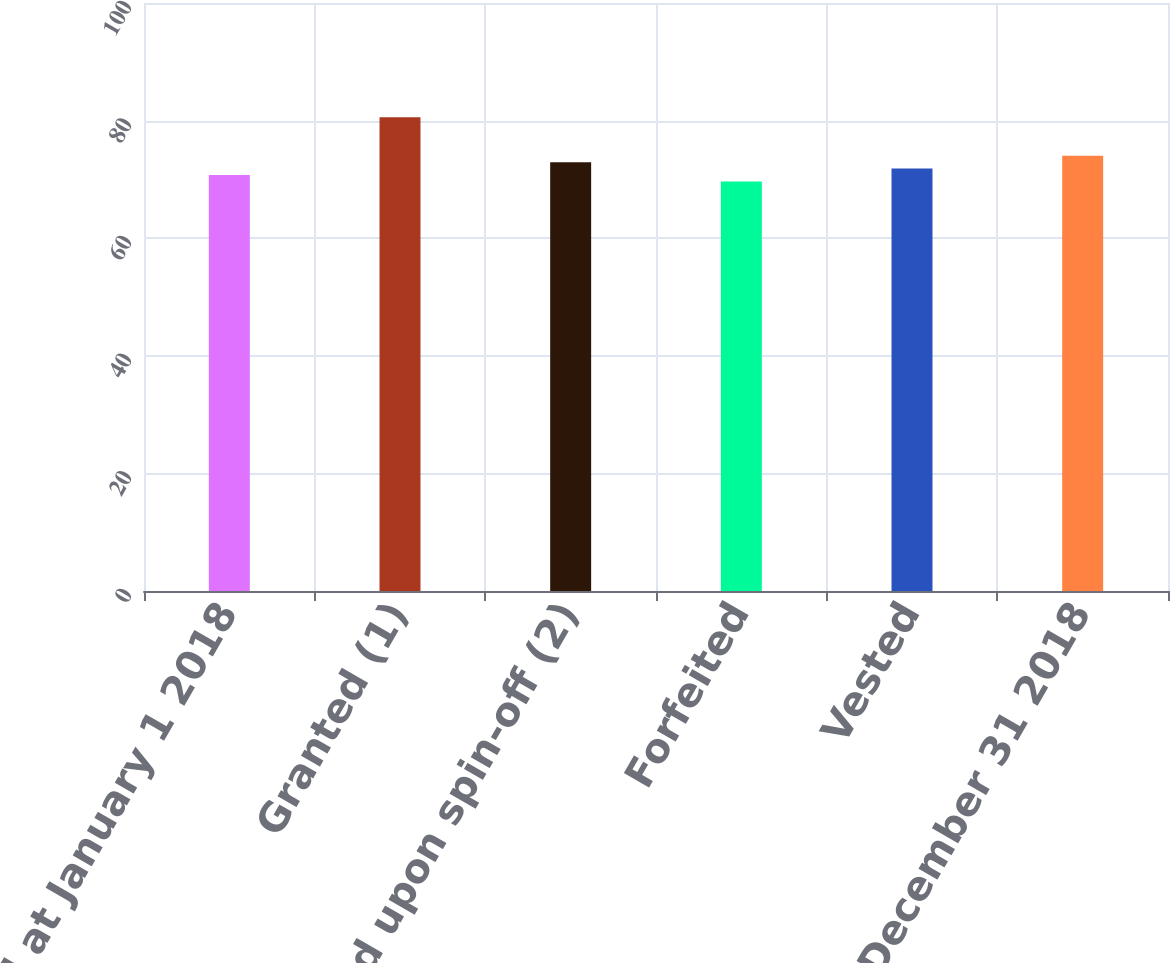Convert chart. <chart><loc_0><loc_0><loc_500><loc_500><bar_chart><fcel>Unvested at January 1 2018<fcel>Granted (1)<fcel>Surrendered upon spin-off (2)<fcel>Forfeited<fcel>Vested<fcel>Unvested at December 31 2018<nl><fcel>70.75<fcel>80.59<fcel>72.93<fcel>69.66<fcel>71.84<fcel>74.02<nl></chart> 